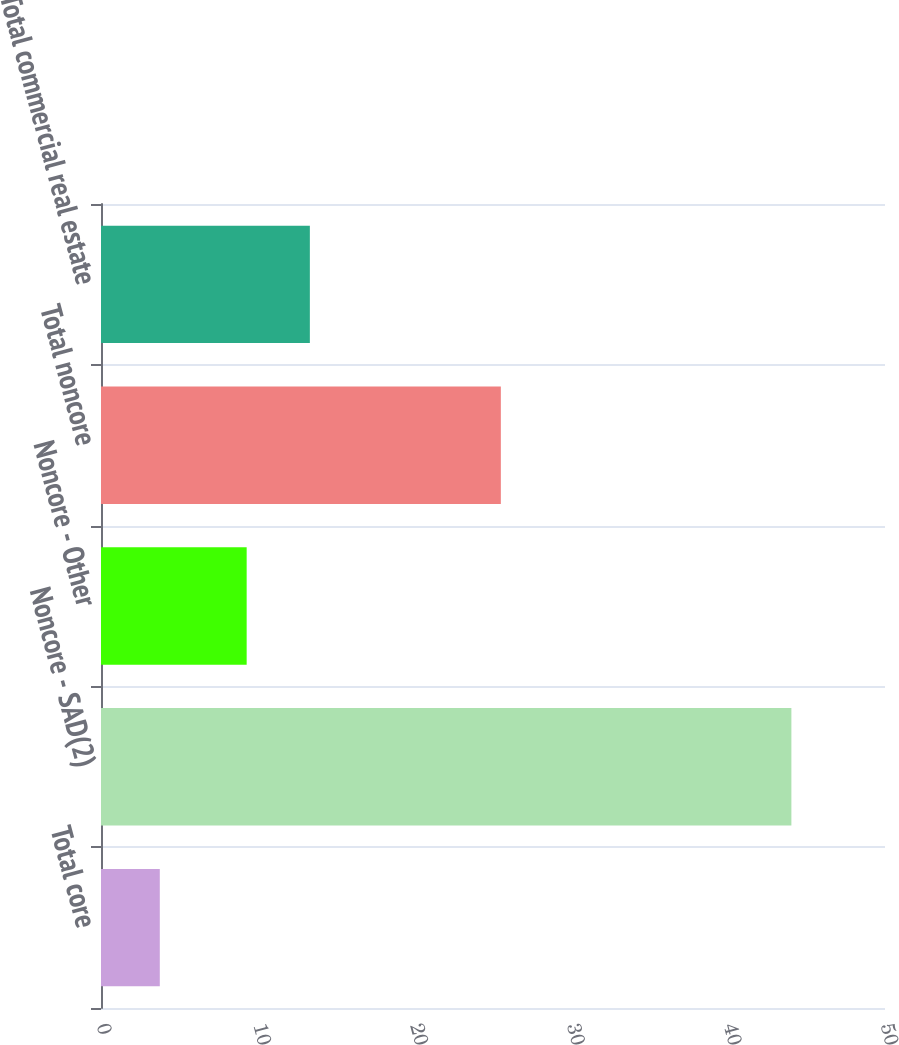Convert chart. <chart><loc_0><loc_0><loc_500><loc_500><bar_chart><fcel>Total core<fcel>Noncore - SAD(2)<fcel>Noncore - Other<fcel>Total noncore<fcel>Total commercial real estate<nl><fcel>3.75<fcel>44.03<fcel>9.29<fcel>25.5<fcel>13.32<nl></chart> 